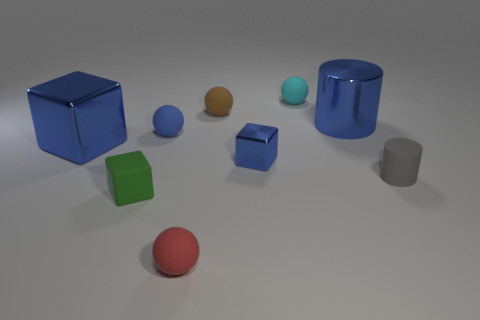Subtract all small metallic blocks. How many blocks are left? 2 Subtract all red balls. How many blue cubes are left? 2 Add 1 small red balls. How many objects exist? 10 Subtract all blue balls. How many balls are left? 3 Subtract all cylinders. How many objects are left? 7 Subtract all red balls. Subtract all brown cubes. How many balls are left? 3 Subtract 0 brown cylinders. How many objects are left? 9 Subtract all brown rubber cubes. Subtract all tiny brown matte things. How many objects are left? 8 Add 9 tiny brown matte spheres. How many tiny brown matte spheres are left? 10 Add 5 blue metal blocks. How many blue metal blocks exist? 7 